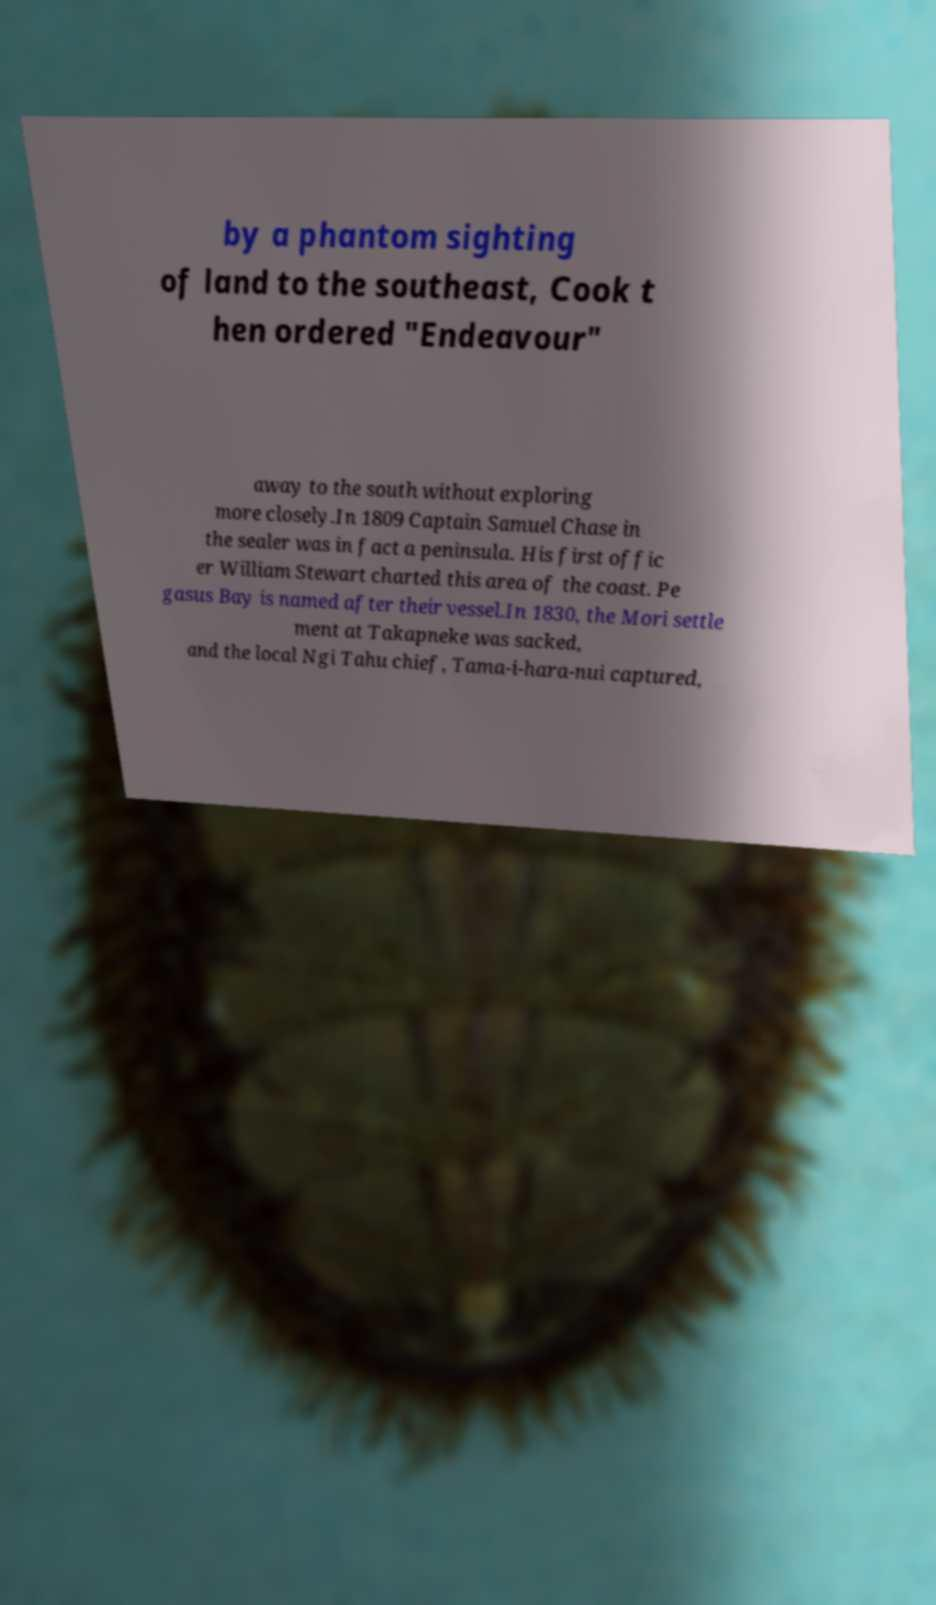Could you assist in decoding the text presented in this image and type it out clearly? by a phantom sighting of land to the southeast, Cook t hen ordered "Endeavour" away to the south without exploring more closely.In 1809 Captain Samuel Chase in the sealer was in fact a peninsula. His first offic er William Stewart charted this area of the coast. Pe gasus Bay is named after their vessel.In 1830, the Mori settle ment at Takapneke was sacked, and the local Ngi Tahu chief, Tama-i-hara-nui captured, 